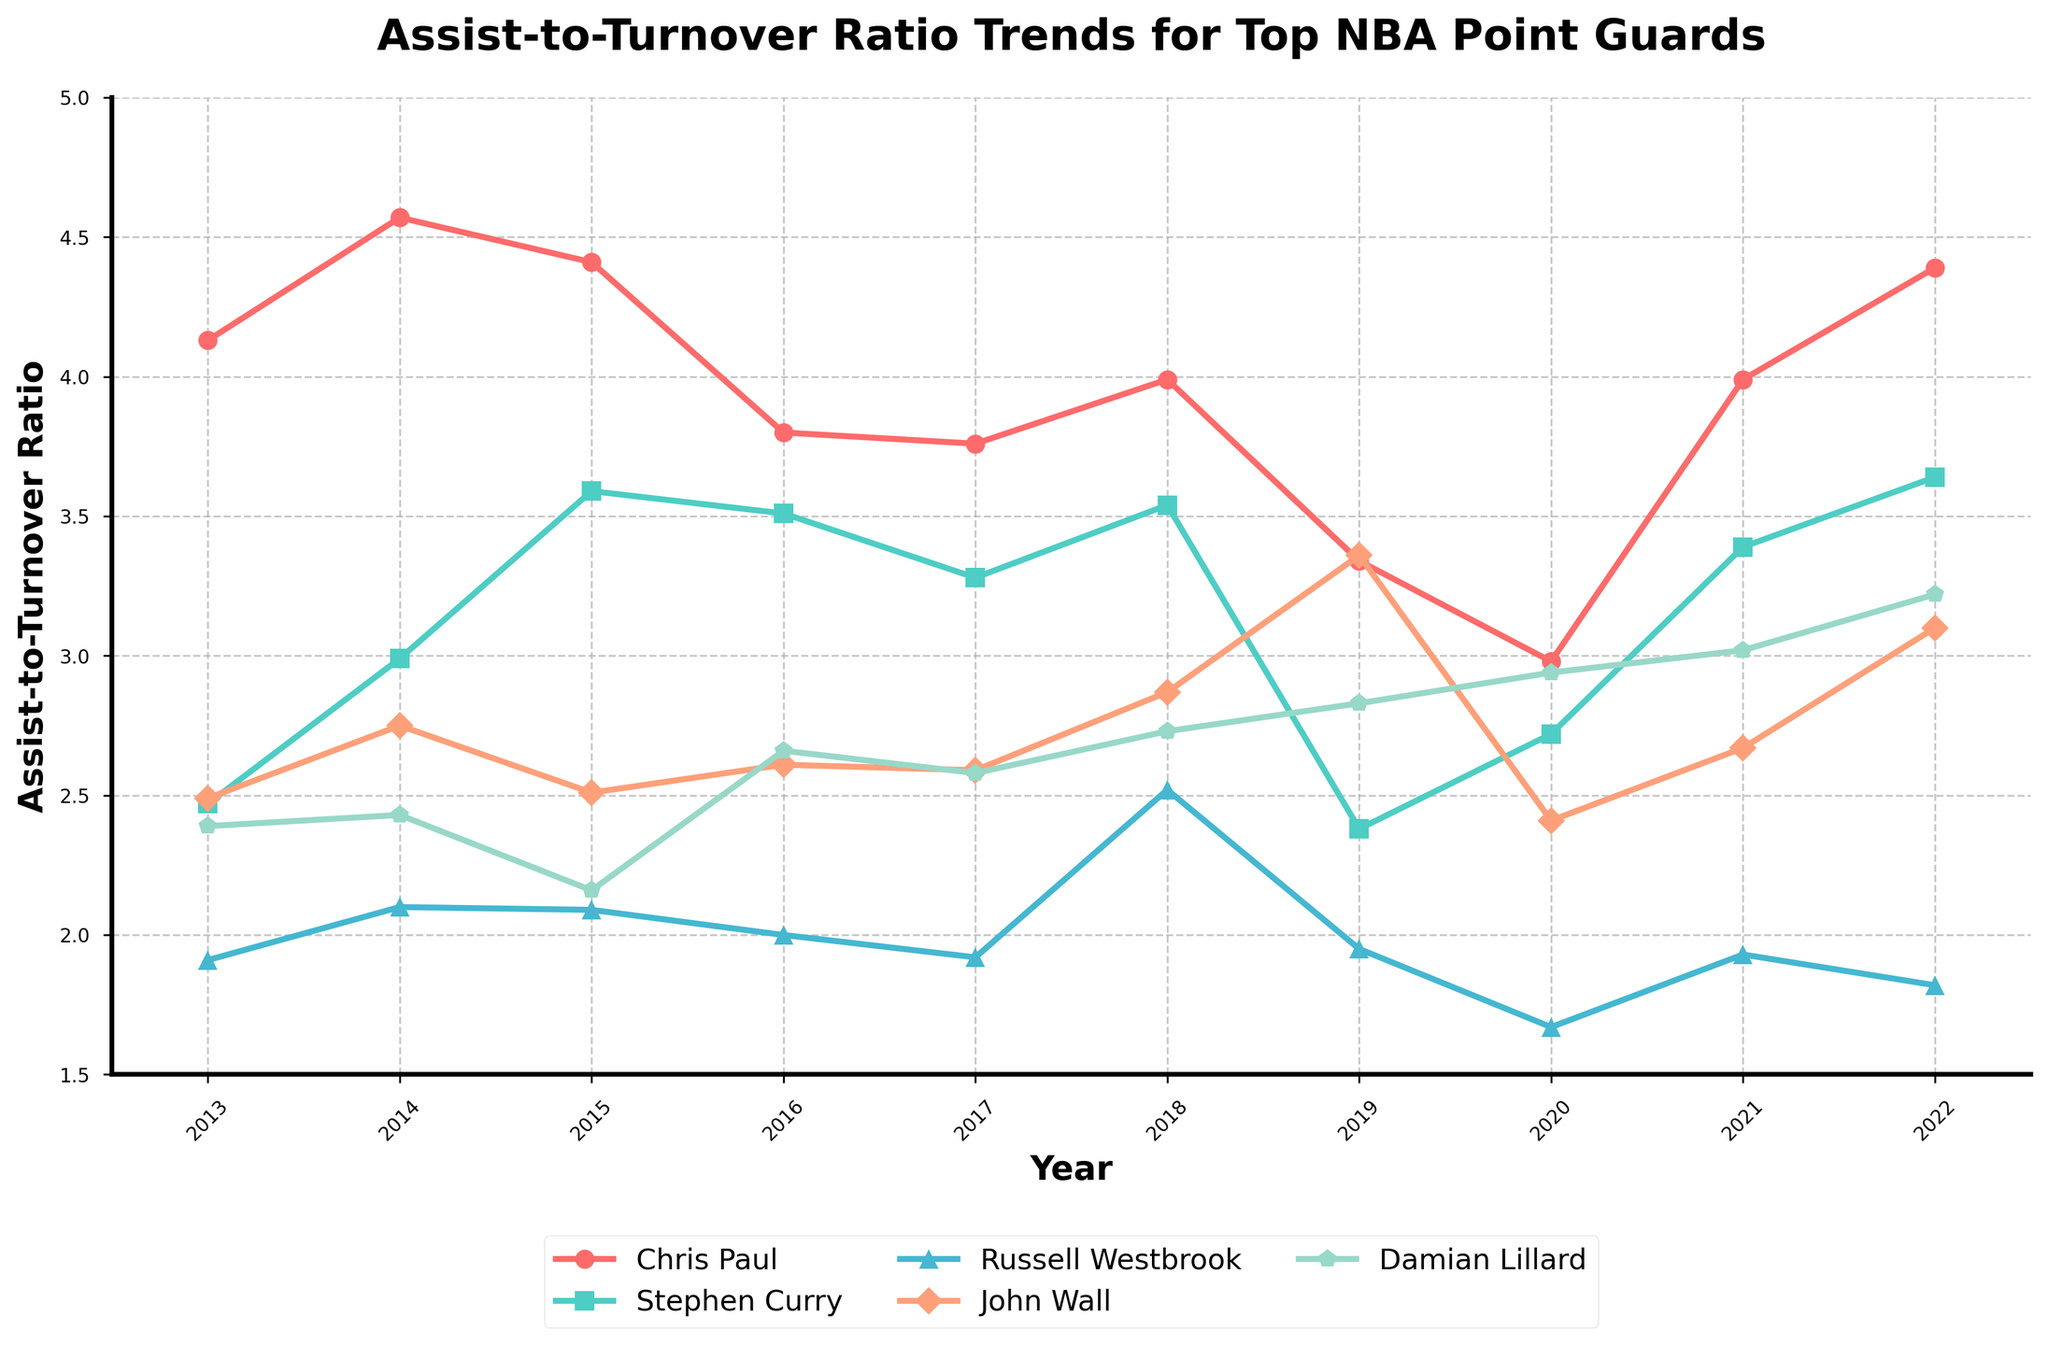What's the Assist-to-Turnover Ratio trend for Chris Paul from 2013 to 2022? To find the trend, observe Chris Paul's line in the plot. Starting from 2013, his ratio increases until 2014, decreases gradually till 2017, then shows some fluctuation until a notable increase in 2021 and reaches back to near 2013 level in 2022.
Answer: Increases, then decreases, fluctuates, finally increases Who had the highest Assist-to-Turnover Ratio in 2022? To identify the player with the highest ratio, look at the endpoints of each line on the rightmost side (2022). Chris Paul's line is highest.
Answer: Chris Paul Compare the 2021 Assist-to-Turnover Ratios for Russell Westbrook and Damian Lillard. Who had the better ratio? Find the 2021 points for both players on the plot. Russell Westbrook’s ratio is lower while Damian Lillard's is higher in 2021.
Answer: Damian Lillard How has Stephen Curry's Assist-to-Turnover Ratio changed from 2013 to 2022? Observe Stephen Curry's line from 2013 to 2022. Initially, it increases until 2015, fluctuates within a certain range, then slightly decreases till 2020, and rises again post-2020.
Answer: Increases, fluctuates, decreases, then increases What is the biggest improvement in Assist-to-Turnover Ratio for any player in consecutive years? Look for the steepest upward segment within each individual player's line. Chris Paul’s increase from 2020 to 2021 is notably steep.
Answer: Chris Paul 2020-2021 Which player maintained the most stable Assist-to-Turnover Ratio over the decade? Look for the flattest line among the players. John Wall's line is relatively flat with less steep increases or decreases compared to others.
Answer: John Wall In which year did John Wall achieve his peak Assist-to-Turnover Ratio? Track the highest point in John Wall’s line. The peak occurred in 2019.
Answer: 2019 Compare the fluctuations of Russell Westbrook and Stephen Curry's Assist-to-Turnover Ratios over the decade. Who had more variability? Observe both players' lines and the extent of their changes. Russell Westbrook's line varies significantly more compared to Stephen Curry's.
Answer: Russell Westbrook What was the average Assist-to-Turnover Ratio of Damian Lillard between 2013 and 2022? Add up values from 2013 to 2022 for Damian Lillard and divide by the number of years. (2.39 + 2.43 + 2.16 + 2.66 + 2.58 + 2.73 + 2.83 + 2.94 + 3.02 + 3.22) / 10 = 2.696
Answer: 2.696 Which year showed the smallest difference in Assist-to-Turnover Ratios between Chris Paul and Stephen Curry? Calculate the year-by-year differences between Chris Paul and Stephen Curry and find the smallest. 2020 has the lowest difference:
Answer: 2020 